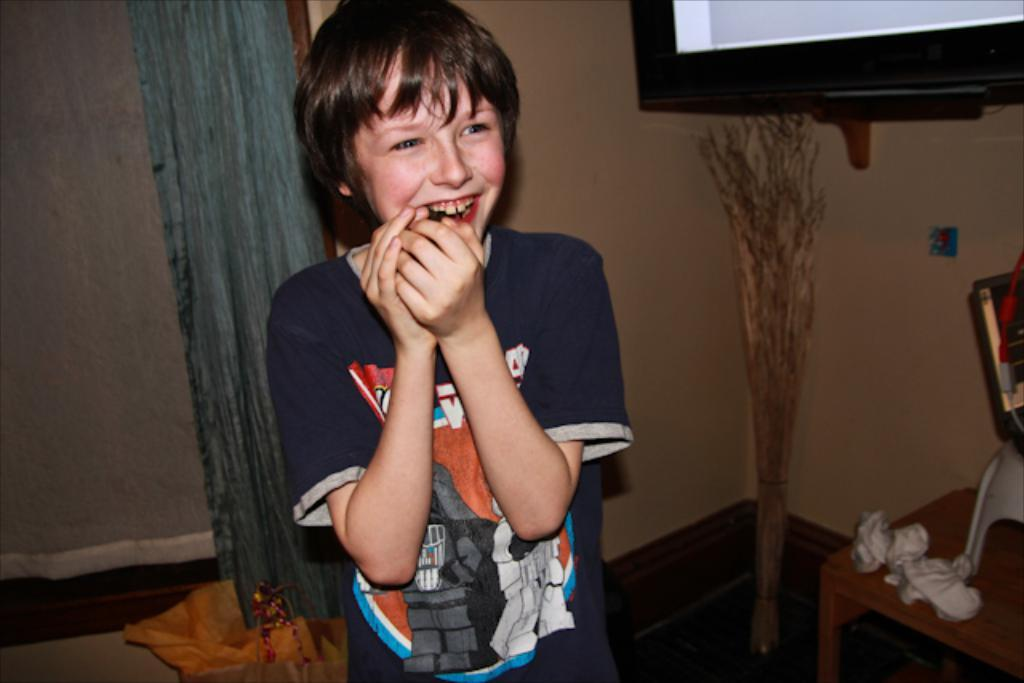Who is present in the image? There is a boy in the image. What is the boy doing in the image? The boy is standing and smiling. What can be seen in the background of the image? There is a curtain, a blanket, wooden sticks, a table, and a television attached to the wall in the background of the image. What type of magic is the boy performing in the image? There is no indication of magic or any magical activity in the image. The boy is simply standing and smiling. 